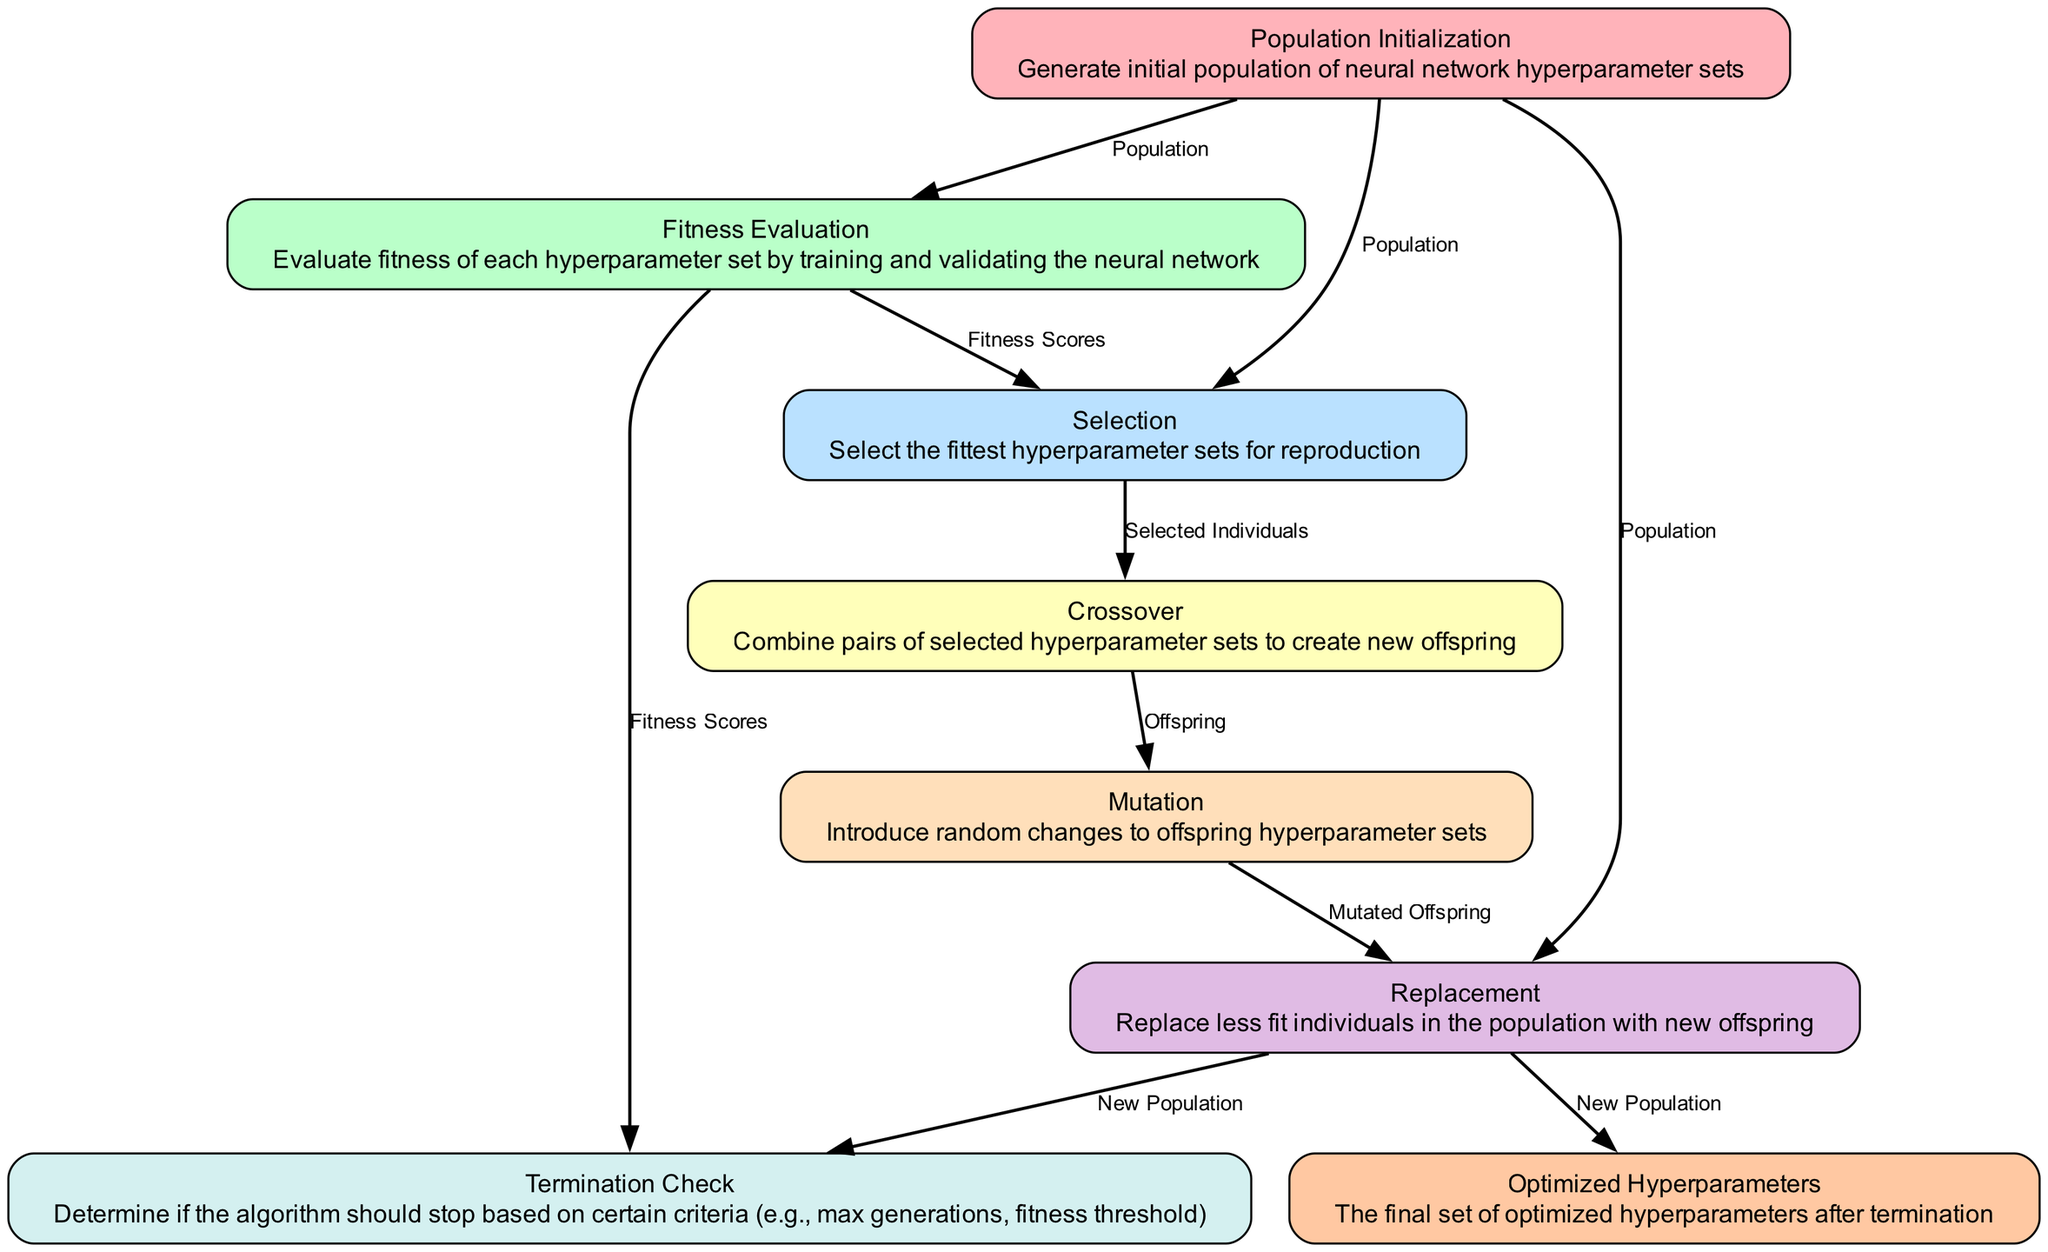What is the input for the selection process? The selection process requires both the population and fitness scores as inputs. This is indicated in the diagram where the 'Selection' node has 'Population' and 'Fitness Scores' listed as its inputs.
Answer: Population, Fitness Scores How many processes are involved in this genetic algorithm workflow? By counting the nodes in the diagram, we see that there are a total of eight processes outlined (from population initialization to optimized hyperparameters).
Answer: Eight What type of process is mutation? In the diagram, the mutation process is labeled as "Introduce random changes to offspring hyperparameter sets," indicating that it is a variation process applied to the offspring. Thus, it is categorized as a mutation process.
Answer: Mutation What is the output of the replacement process? The replacement process produces a new population as its output, which is directly stated in the diagram.
Answer: New Population Which process follows fitness evaluation? According to the flow of the diagram, the selection process follows the fitness evaluation process, as indicated by the arrow connecting these two nodes.
Answer: Selection What are the inputs for the crossover process? The crossover process takes 'Selected Individuals' as its input, based on the diagram which explicitly states this.
Answer: Selected Individuals How does the termination check determine if the algorithm should stop? The termination check evaluates the new population and fitness scores to determine if it meets certain stopping criteria (like maximum generations or fitness thresholds). This relationship is depicted in the diagram with the inputs listed for the 'Termination Check' process.
Answer: Based on stopping criteria What is the final output of the genetic algorithm? The final output of the workflow is the best hyperparameter set, which is identified in the diagram at the last node labeled 'Optimized Hyperparameters'.
Answer: Best Hyperparameter Set 